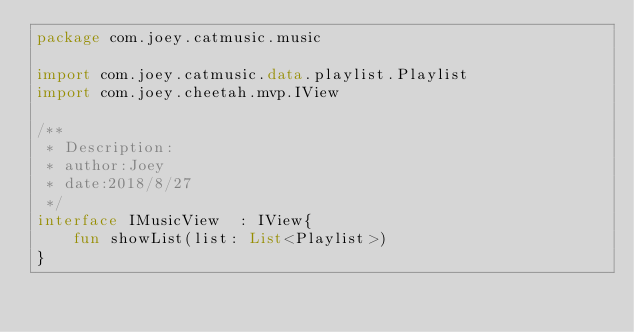Convert code to text. <code><loc_0><loc_0><loc_500><loc_500><_Kotlin_>package com.joey.catmusic.music

import com.joey.catmusic.data.playlist.Playlist
import com.joey.cheetah.mvp.IView

/**
 * Description:
 * author:Joey
 * date:2018/8/27
 */
interface IMusicView  : IView{
    fun showList(list: List<Playlist>)
}</code> 